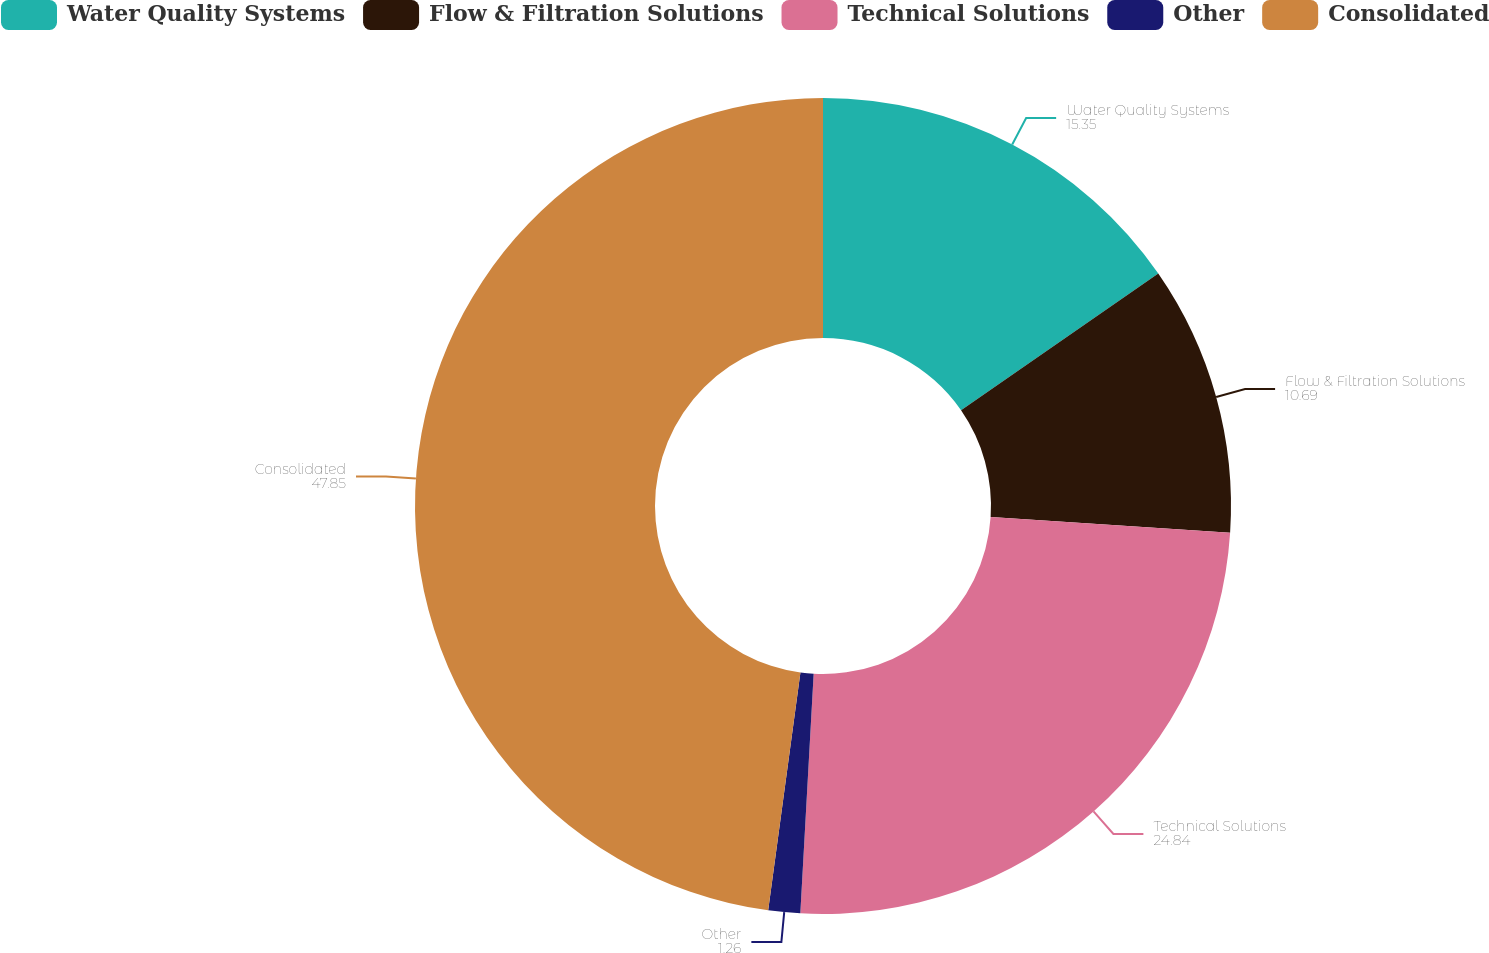Convert chart. <chart><loc_0><loc_0><loc_500><loc_500><pie_chart><fcel>Water Quality Systems<fcel>Flow & Filtration Solutions<fcel>Technical Solutions<fcel>Other<fcel>Consolidated<nl><fcel>15.35%<fcel>10.69%<fcel>24.84%<fcel>1.26%<fcel>47.85%<nl></chart> 